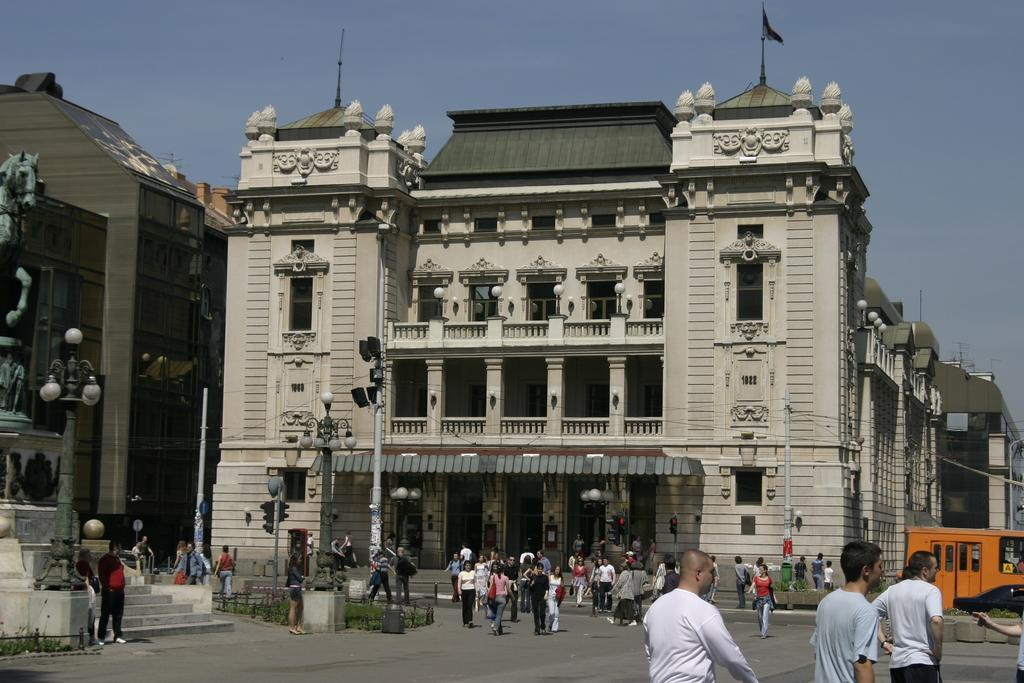What type of structures are present in the image? There are buildings in the image. What are the people in the image doing? The people are walking on the road in front of the buildings. What can be seen in the background of the image? The sky is visible in the background of the image. Can you hear the whistle of the boy in the image? There is no boy or whistle present in the image. 